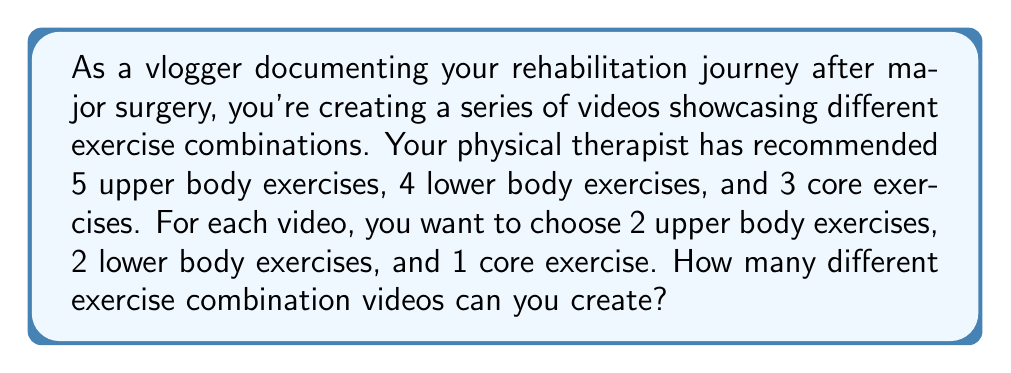Show me your answer to this math problem. Let's break this down step-by-step:

1) For upper body exercises:
   We need to choose 2 exercises out of 5. This is a combination problem.
   The number of ways to do this is given by $\binom{5}{2}$.
   
   $$\binom{5}{2} = \frac{5!}{2!(5-2)!} = \frac{5 \cdot 4}{2 \cdot 1} = 10$$

2) For lower body exercises:
   We need to choose 2 exercises out of 4.
   The number of ways to do this is $\binom{4}{2}$.
   
   $$\binom{4}{2} = \frac{4!}{2!(4-2)!} = \frac{4 \cdot 3}{2 \cdot 1} = 6$$

3) For core exercises:
   We need to choose 1 exercise out of 3.
   The number of ways to do this is $\binom{3}{1}$.
   
   $$\binom{3}{1} = \frac{3!}{1!(3-1)!} = 3$$

4) Now, according to the Multiplication Principle, if we have $m$ ways of doing something, $n$ ways of doing another thing, and $p$ ways of doing a third thing, then there are $m \cdot n \cdot p$ ways of doing all three things.

Therefore, the total number of different exercise combination videos is:

$$10 \cdot 6 \cdot 3 = 180$$
Answer: 180 different exercise combination videos 